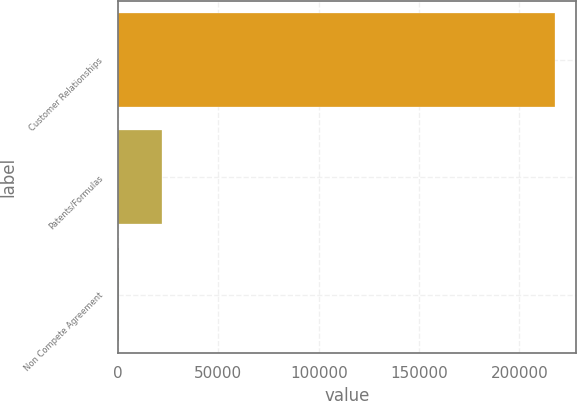<chart> <loc_0><loc_0><loc_500><loc_500><bar_chart><fcel>Customer Relationships<fcel>Patents/Formulas<fcel>Non Compete Agreement<nl><fcel>217595<fcel>22061.9<fcel>336<nl></chart> 